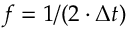Convert formula to latex. <formula><loc_0><loc_0><loc_500><loc_500>f = 1 / ( 2 \cdot \Delta t )</formula> 